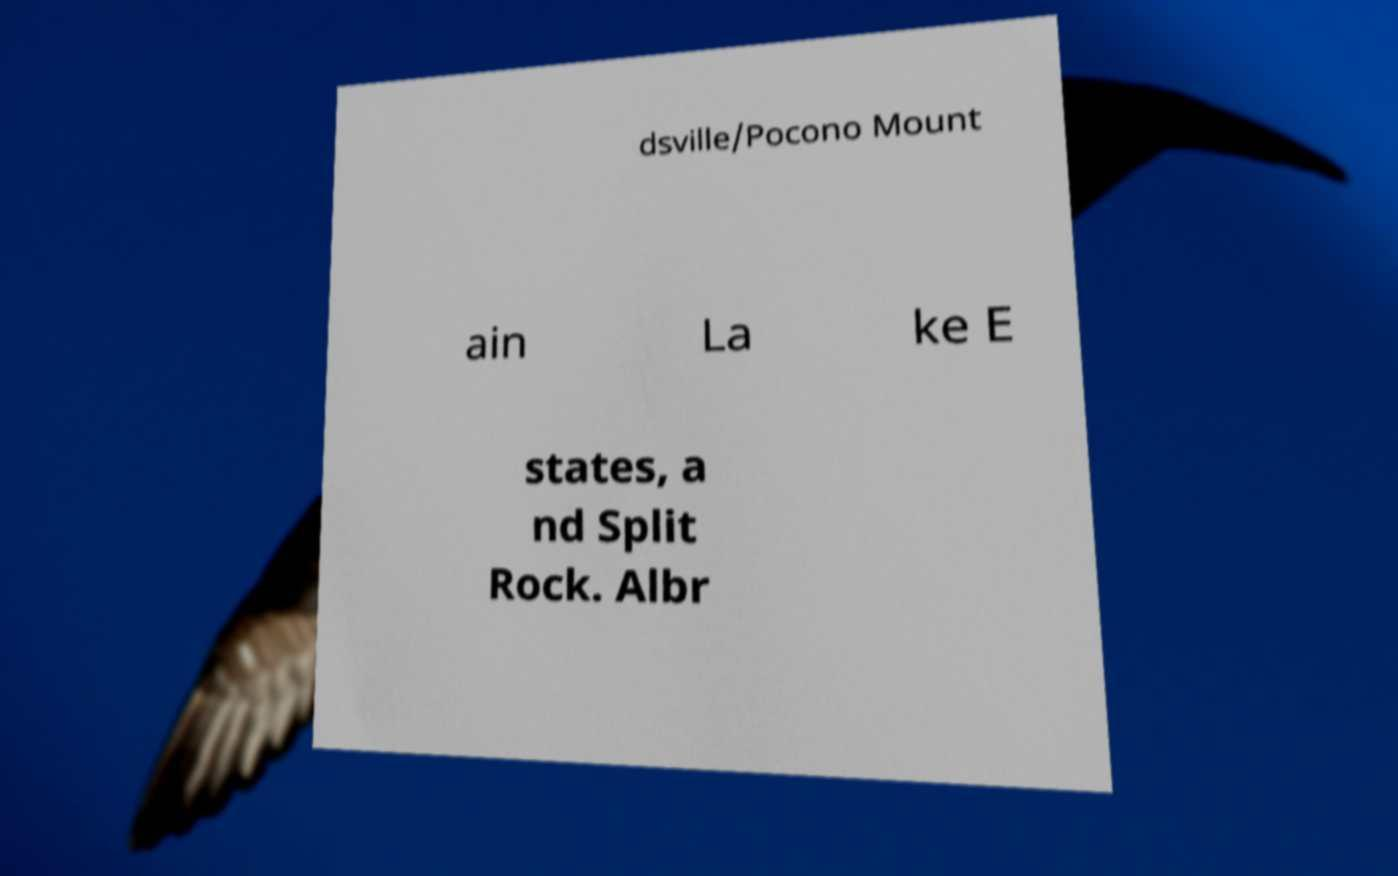Please read and relay the text visible in this image. What does it say? dsville/Pocono Mount ain La ke E states, a nd Split Rock. Albr 